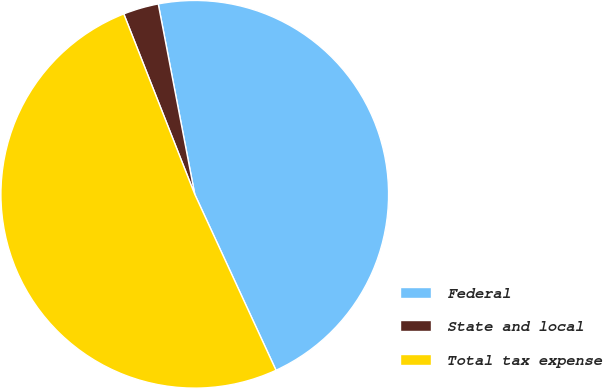Convert chart. <chart><loc_0><loc_0><loc_500><loc_500><pie_chart><fcel>Federal<fcel>State and local<fcel>Total tax expense<nl><fcel>46.13%<fcel>2.95%<fcel>50.92%<nl></chart> 